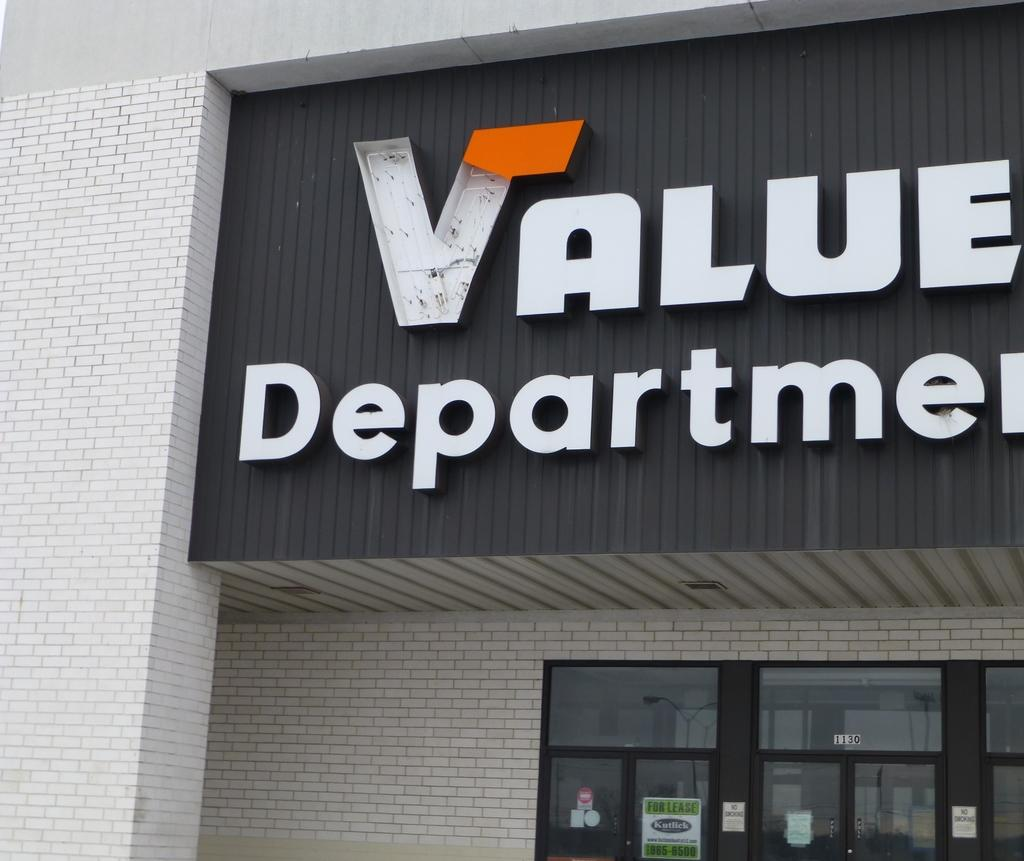What is written or displayed on the building in the foreground of the image? There is text on the building in the foreground of the image. What type of entrance can be seen in the bottom part of the image? There are glass doors in the bottom part of the image. What is displayed on the glass doors? There are posters on the glass doors. Can you see a snail playing volleyball on the posters displayed on the glass doors? No, there is no snail or volleyball depicted on the posters displayed on the glass doors. 